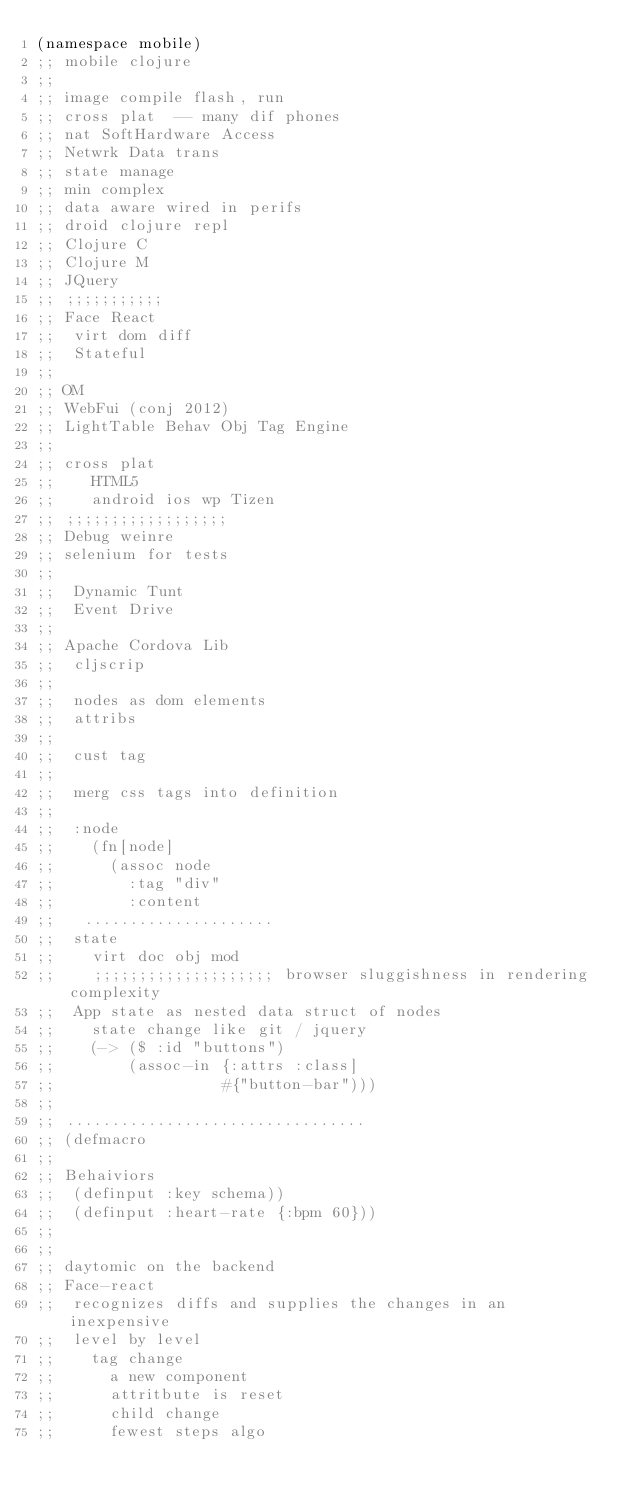<code> <loc_0><loc_0><loc_500><loc_500><_Clojure_>(namespace mobile) 
;; mobile clojure 
;; 
;; image compile flash, run 
;; cross plat  -- many dif phones 
;; nat SoftHardware Access 
;; Netwrk Data trans 
;; state manage
;; min complex
;; data aware wired in perifs
;; droid clojure repl 
;; Clojure C 
;; Clojure M 
;; JQuery 
;; ;;;;;;;;;;;
;; Face React 
;;  virt dom diff
;;  Stateful
;;
;; OM 
;; WebFui (conj 2012) 
;; LightTable Behav Obj Tag Engine
;;
;; cross plat 
;;    HTML5 
;;    android ios wp Tizen 
;; ;;;;;;;;;;;;;;;;;;
;; Debug weinre 
;; selenium for tests 
;;
;;  Dynamic Tunt  
;;  Event Drive
;;
;; Apache Cordova Lib 
;;  cljscrip 
;;
;;  nodes as dom elements 
;;  attribs 
;;
;;  cust tag 
;;  
;;  merg css tags into definition 
;;
;;  :node 
;;    (fn[node] 
;;      (assoc node
;;        :tag "div" 
;;        :content 
;;   .....................
;;  state 
;;    virt doc obj mod
;;    ;;;;;;;;;;;;;;;;;;;; browser sluggishness in rendering complexity 
;;  App state as nested data struct of nodes 
;;    state change like git / jquery 
;;    (-> ($ :id "buttons") 
;;        (assoc-in {:attrs :class] 
;;                  #{"button-bar")))
;; 
;; .................................
;; (defmacro  
;;
;; Behaiviors 
;;  (definput :key schema))
;;  (definput :heart-rate {:bpm 60})) 
;; 
;;
;; daytomic on the backend 
;; Face-react 
;;  recognizes diffs and supplies the changes in an inexpensive 
;;  level by level 
;;    tag change 
;;      a new component 
;;      attritbute is reset
;;      child change 
;;      fewest steps algo </code> 